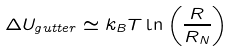Convert formula to latex. <formula><loc_0><loc_0><loc_500><loc_500>\Delta U _ { g u t t e r } \simeq k _ { B } T \ln \left ( \frac { R } { R _ { N } } \right )</formula> 